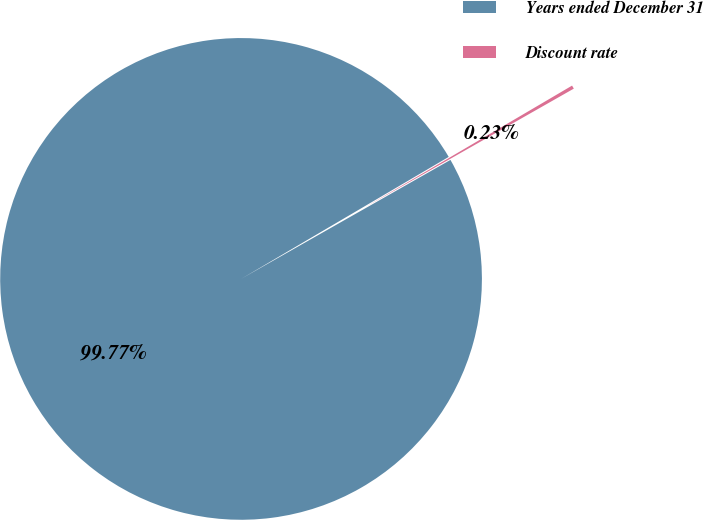Convert chart. <chart><loc_0><loc_0><loc_500><loc_500><pie_chart><fcel>Years ended December 31<fcel>Discount rate<nl><fcel>99.77%<fcel>0.23%<nl></chart> 